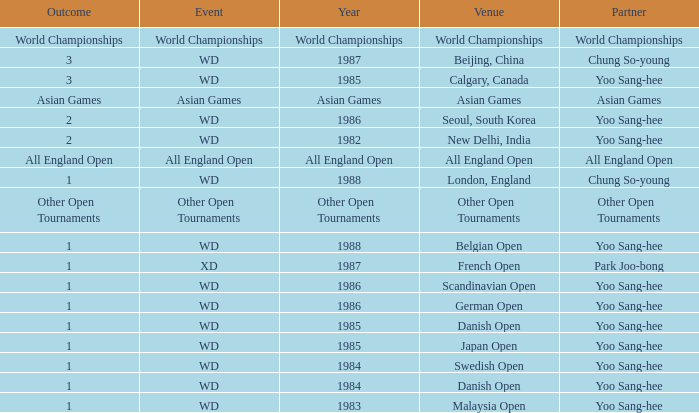What is the Outcome in the Malaysia Open with Partner Yoo Sang-Hee? 1.0. 